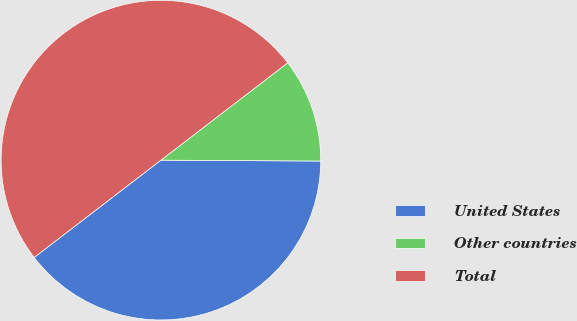<chart> <loc_0><loc_0><loc_500><loc_500><pie_chart><fcel>United States<fcel>Other countries<fcel>Total<nl><fcel>39.49%<fcel>10.51%<fcel>50.0%<nl></chart> 